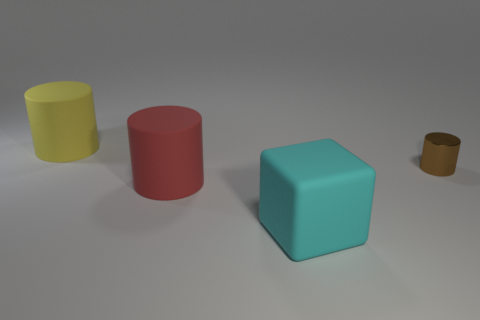Does the large cube have the same material as the brown cylinder?
Offer a very short reply. No. Is the tiny brown shiny thing the same shape as the large red matte thing?
Give a very brief answer. Yes. Is the number of matte blocks behind the matte cube the same as the number of red things to the right of the yellow matte thing?
Give a very brief answer. No. What is the color of the block that is made of the same material as the large yellow object?
Make the answer very short. Cyan. What number of red cylinders are made of the same material as the tiny brown object?
Offer a very short reply. 0. Does the cylinder that is in front of the brown metal thing have the same color as the block?
Provide a succinct answer. No. What number of metallic things are the same shape as the yellow matte object?
Make the answer very short. 1. Are there the same number of yellow things behind the big yellow thing and small yellow shiny blocks?
Provide a succinct answer. Yes. What is the color of the other cylinder that is the same size as the yellow cylinder?
Offer a terse response. Red. Are there any big cyan rubber things that have the same shape as the yellow matte thing?
Make the answer very short. No. 